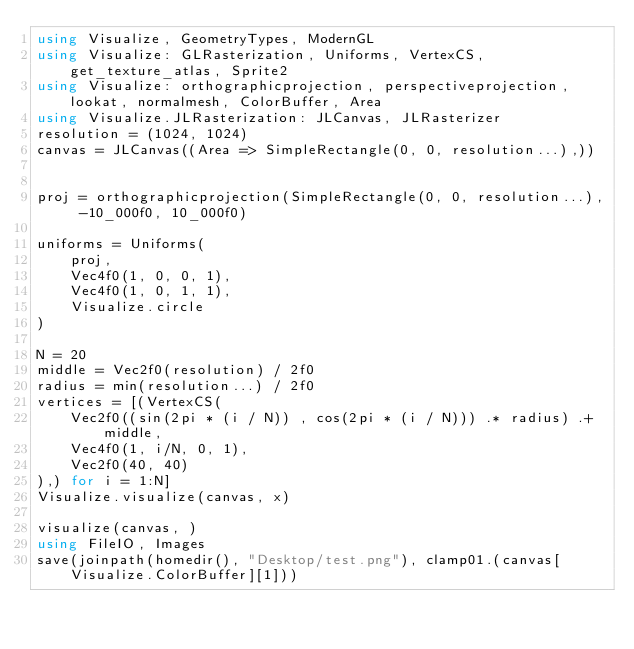Convert code to text. <code><loc_0><loc_0><loc_500><loc_500><_Julia_>using Visualize, GeometryTypes, ModernGL
using Visualize: GLRasterization, Uniforms, VertexCS, get_texture_atlas, Sprite2
using Visualize: orthographicprojection, perspectiveprojection, lookat, normalmesh, ColorBuffer, Area
using Visualize.JLRasterization: JLCanvas, JLRasterizer
resolution = (1024, 1024)
canvas = JLCanvas((Area => SimpleRectangle(0, 0, resolution...),))


proj = orthographicprojection(SimpleRectangle(0, 0, resolution...), -10_000f0, 10_000f0)

uniforms = Uniforms(
    proj,
    Vec4f0(1, 0, 0, 1),
    Vec4f0(1, 0, 1, 1),
    Visualize.circle
)

N = 20
middle = Vec2f0(resolution) / 2f0
radius = min(resolution...) / 2f0
vertices = [(VertexCS(
    Vec2f0((sin(2pi * (i / N)) , cos(2pi * (i / N))) .* radius) .+ middle,
    Vec4f0(1, i/N, 0, 1),
    Vec2f0(40, 40)
),) for i = 1:N]
Visualize.visualize(canvas, x)

visualize(canvas, )
using FileIO, Images
save(joinpath(homedir(), "Desktop/test.png"), clamp01.(canvas[Visualize.ColorBuffer][1]))
</code> 